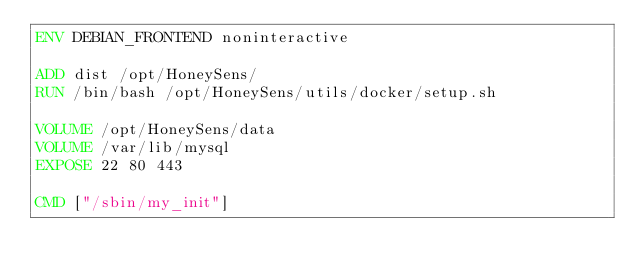Convert code to text. <code><loc_0><loc_0><loc_500><loc_500><_Dockerfile_>ENV DEBIAN_FRONTEND noninteractive

ADD dist /opt/HoneySens/
RUN /bin/bash /opt/HoneySens/utils/docker/setup.sh

VOLUME /opt/HoneySens/data
VOLUME /var/lib/mysql
EXPOSE 22 80 443

CMD ["/sbin/my_init"]
</code> 